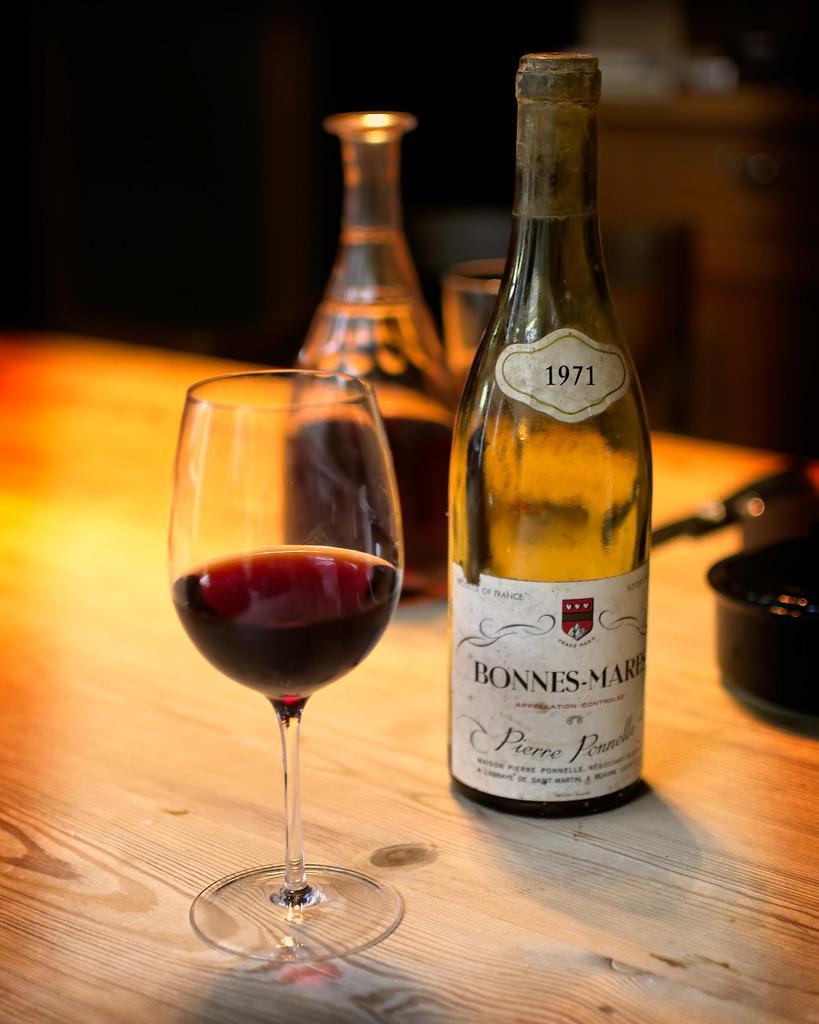Can you describe this image briefly? In this image, we can see wooden table. On top of it, we can see wine glass, wine bottle. Here right side, there is a bottle. On top of it, we can see sticker. Here we can see pan. 